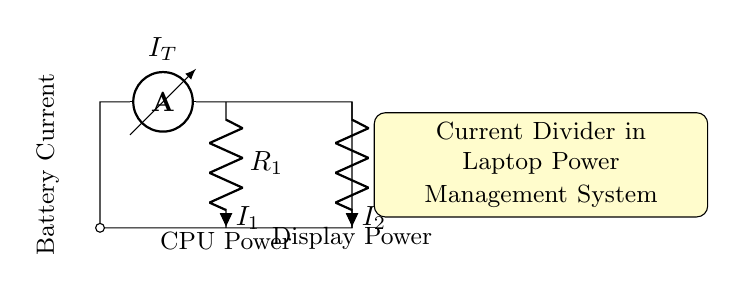What is the total current entering the circuit? The total current, indicated by the ammeter, is represented as I_T in the diagram. It is the sum of the currents through the two resistors I_1 and I_2.
Answer: I_T What are the components present in this circuit? The components visible in the circuit diagram include an ammeter (I_T), two resistors (R_1 and R_2), and connections that lead to power for both CPU and display.
Answer: Ammeter, Resistors What do the resistors R_1 and R_2 represent? In this context, R_1 and R_2 represent the pathways for current divided between the CPU and display. Their values determine how current is distributed.
Answer: CPU Power and Display Power What is the relationship between I_1 and I_2? According to the current divider rule, the current I_1 through resistor R_1 and the current I_2 through resistor R_2 are inversely proportional to their resistances.
Answer: Inversely proportional How is the battery current defined in the circuit? The battery current is represented at the top of the ammeter and is the initial supply before the current divides into I_1 and I_2 at the junctions of resistors R_1 and R_2.
Answer: Battery Current How does the current divider affect battery usage in a laptop? The current divider allows efficient division of current between multiple loads (CPU and display), minimizing waste and optimizing battery life by ensuring each component receives only what it needs.
Answer: Efficient use of battery 